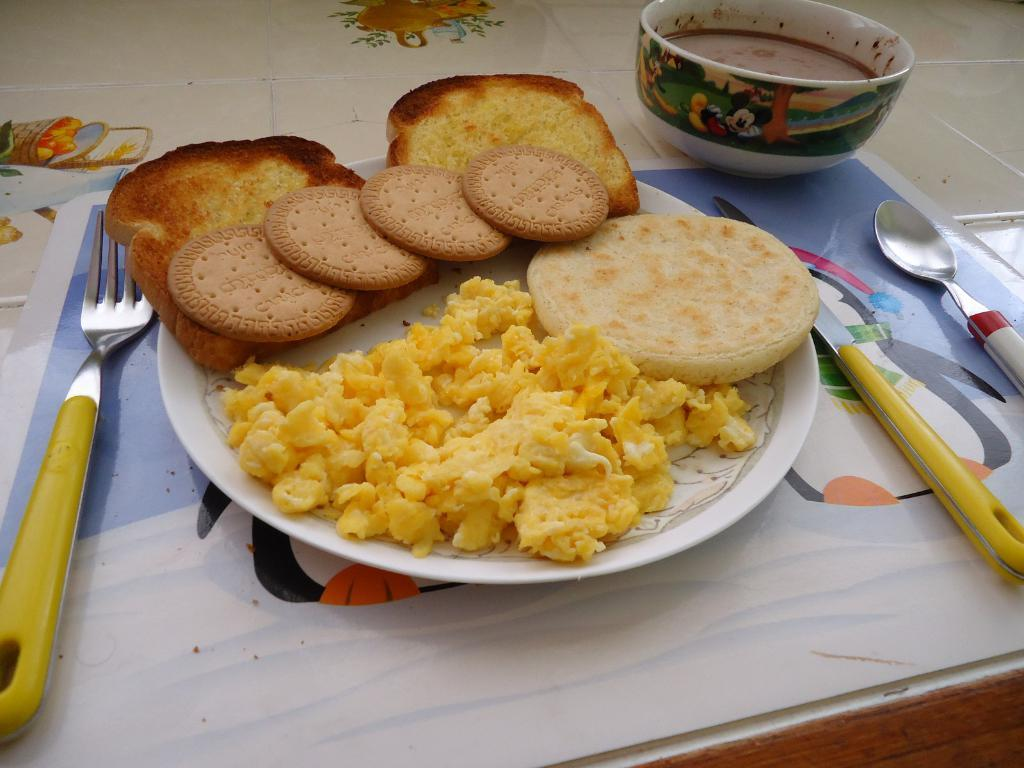What is on the plate in the image? There are food items on a plate in the image. What utensils are visible in the image? There is a spoon, a knife, and a fork in the image. What else can be seen in the image besides the plate and utensils? There is a bowl and other objects present in the image. How many children are laughing at the bun in the image? There are no children or buns present in the image. 